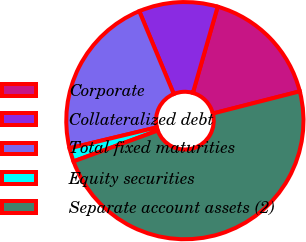Convert chart to OTSL. <chart><loc_0><loc_0><loc_500><loc_500><pie_chart><fcel>Corporate<fcel>Collateralized debt<fcel>Total fixed maturities<fcel>Equity securities<fcel>Separate account assets (2)<nl><fcel>16.57%<fcel>10.74%<fcel>22.46%<fcel>1.84%<fcel>48.39%<nl></chart> 